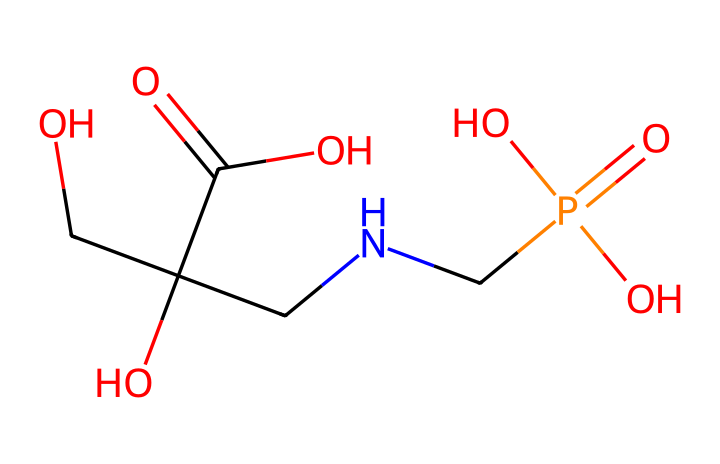What is the molecular formula of glyphosate? To determine the molecular formula, we can count the number of each type of atom in the SMILES representation. Glyphosate contains carbon (C), hydrogen (H), nitrogen (N), oxygen (O) atoms, and counting these gives us C3H8N5O5.
Answer: C3H8N5O5 How many carbon atoms are present in glyphosate? In the SMILES representation, we can identify the carbon atoms (C). There are three distinct C symbols in the representation.
Answer: 3 What type of functional groups are present in glyphosate? By examining the SMILES, we see the presence of a carboxylic acid group (-COOH), an amine group (-NH), and a phosphonic acid group (-PO3H2), which are characteristic of glyphosate.
Answer: carboxylic acid, amine, phosphonic acid Which atom in the glyphosate structure is responsible for its herbicidal properties? Glyphosate has a phosphonate group, which is highly polar and interacts with specific pathways in plants, inhibiting essential amino acids. This group is key to its function as an herbicide.
Answer: phosphonate group What is the total number of oxygen atoms in glyphosate? In the SMILES representation, we can count the number of O symbols, which appear five times, indicating the presence of five oxygen atoms in the structure.
Answer: 5 How many total bonds are indicated in the SMILES for glyphosate? The SMILES notation indicates each bond explicitly, and by analyzing the structure, we can identify a total of eight bonds (both single and double) connecting the atoms.
Answer: 8 